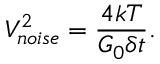Convert formula to latex. <formula><loc_0><loc_0><loc_500><loc_500>V _ { n o i s e } ^ { 2 } = \frac { 4 k T } { G _ { 0 } \delta t } .</formula> 